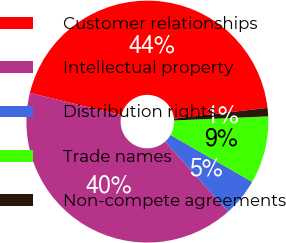Convert chart. <chart><loc_0><loc_0><loc_500><loc_500><pie_chart><fcel>Customer relationships<fcel>Intellectual property<fcel>Distribution rights<fcel>Trade names<fcel>Non-compete agreements<nl><fcel>44.39%<fcel>40.45%<fcel>5.06%<fcel>8.99%<fcel>1.12%<nl></chart> 